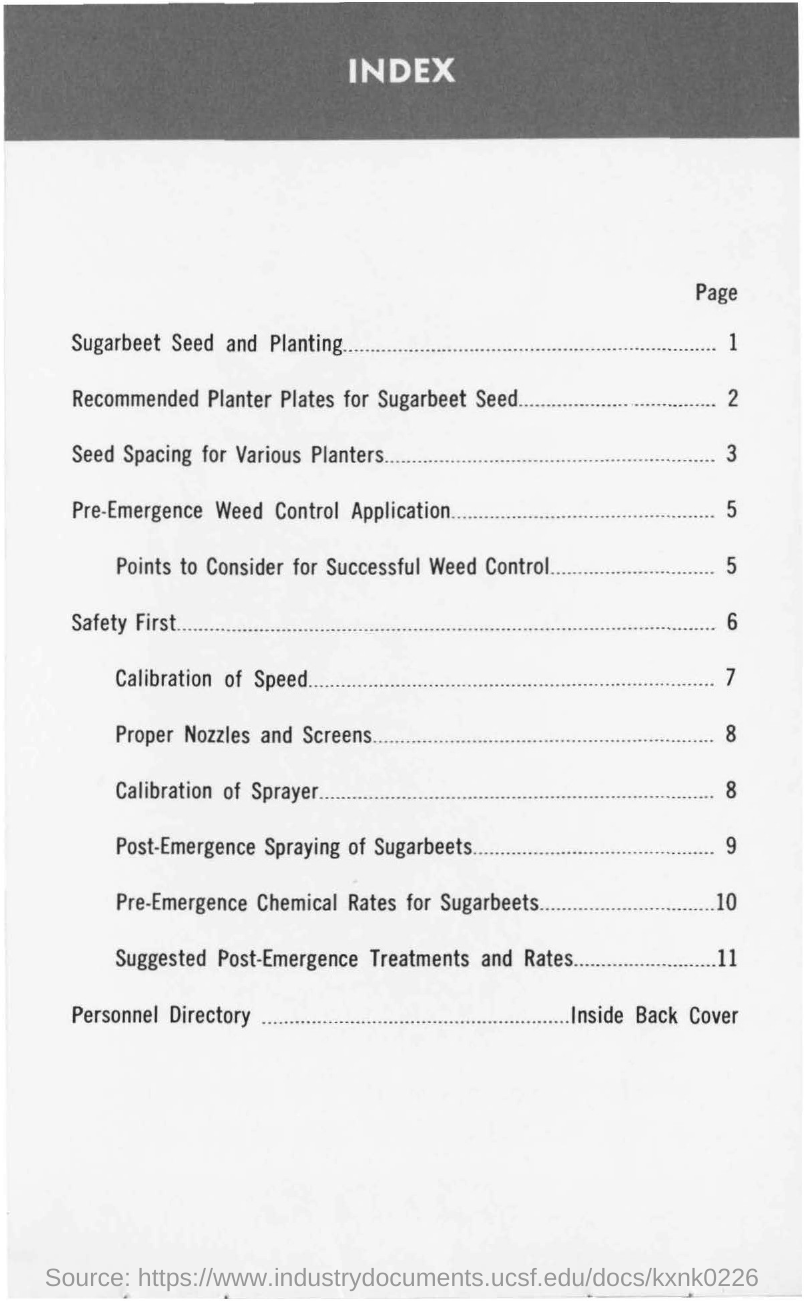What is the page number of the content 'sugarbeet seed and planting'?
Provide a succinct answer. 1. What is the page number of the content 'safety first'?
Keep it short and to the point. 6. What is the page number of the content 'calibration of speed'?
Your answer should be compact. 7. What is the page number of the content 'seed spacing for various planters'?
Offer a very short reply. 3. 